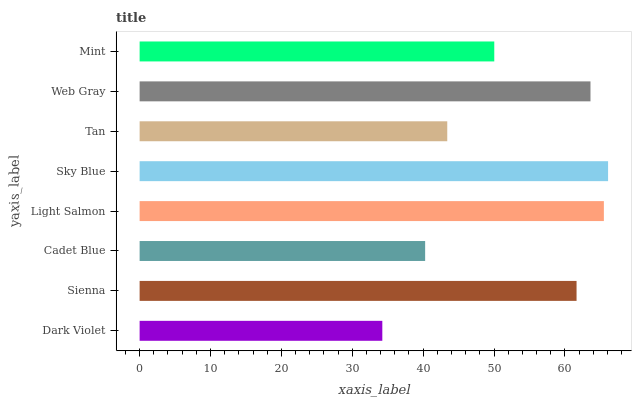Is Dark Violet the minimum?
Answer yes or no. Yes. Is Sky Blue the maximum?
Answer yes or no. Yes. Is Sienna the minimum?
Answer yes or no. No. Is Sienna the maximum?
Answer yes or no. No. Is Sienna greater than Dark Violet?
Answer yes or no. Yes. Is Dark Violet less than Sienna?
Answer yes or no. Yes. Is Dark Violet greater than Sienna?
Answer yes or no. No. Is Sienna less than Dark Violet?
Answer yes or no. No. Is Sienna the high median?
Answer yes or no. Yes. Is Mint the low median?
Answer yes or no. Yes. Is Light Salmon the high median?
Answer yes or no. No. Is Tan the low median?
Answer yes or no. No. 